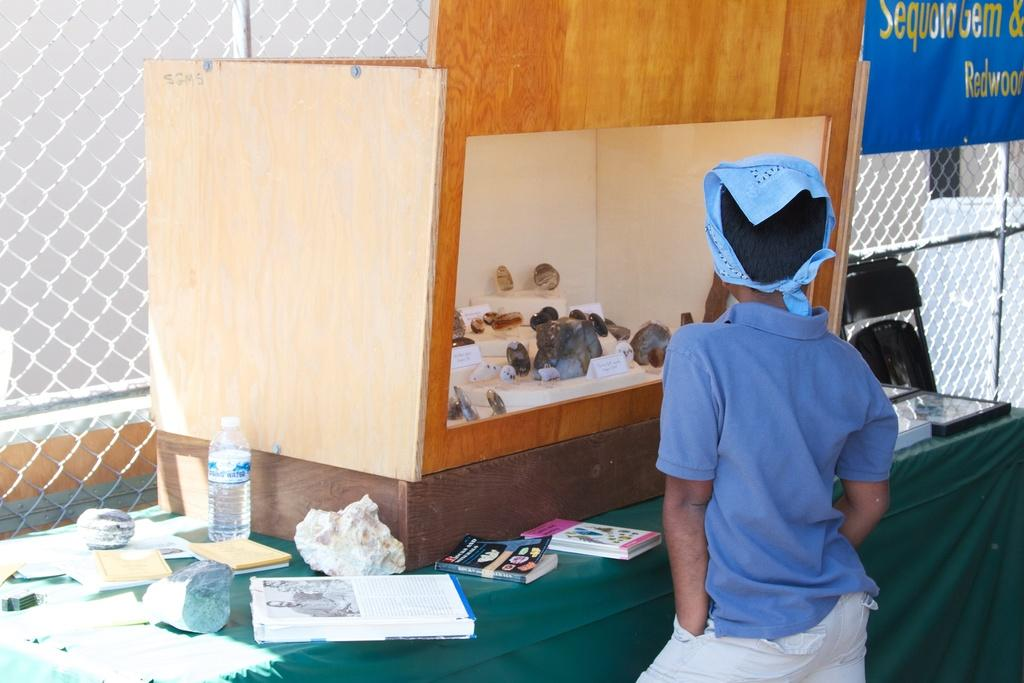What is the boy doing in the image? The boy is standing at the table in the image. What objects are on the table with the boy? There is a water bottle and books on the table. Is there any furniture present on the table? Yes, there is a chair on the table. What can be seen in the background of the image? There is a grill and a wall in the background. What type of army is present in the image? There is no army present in the image. 